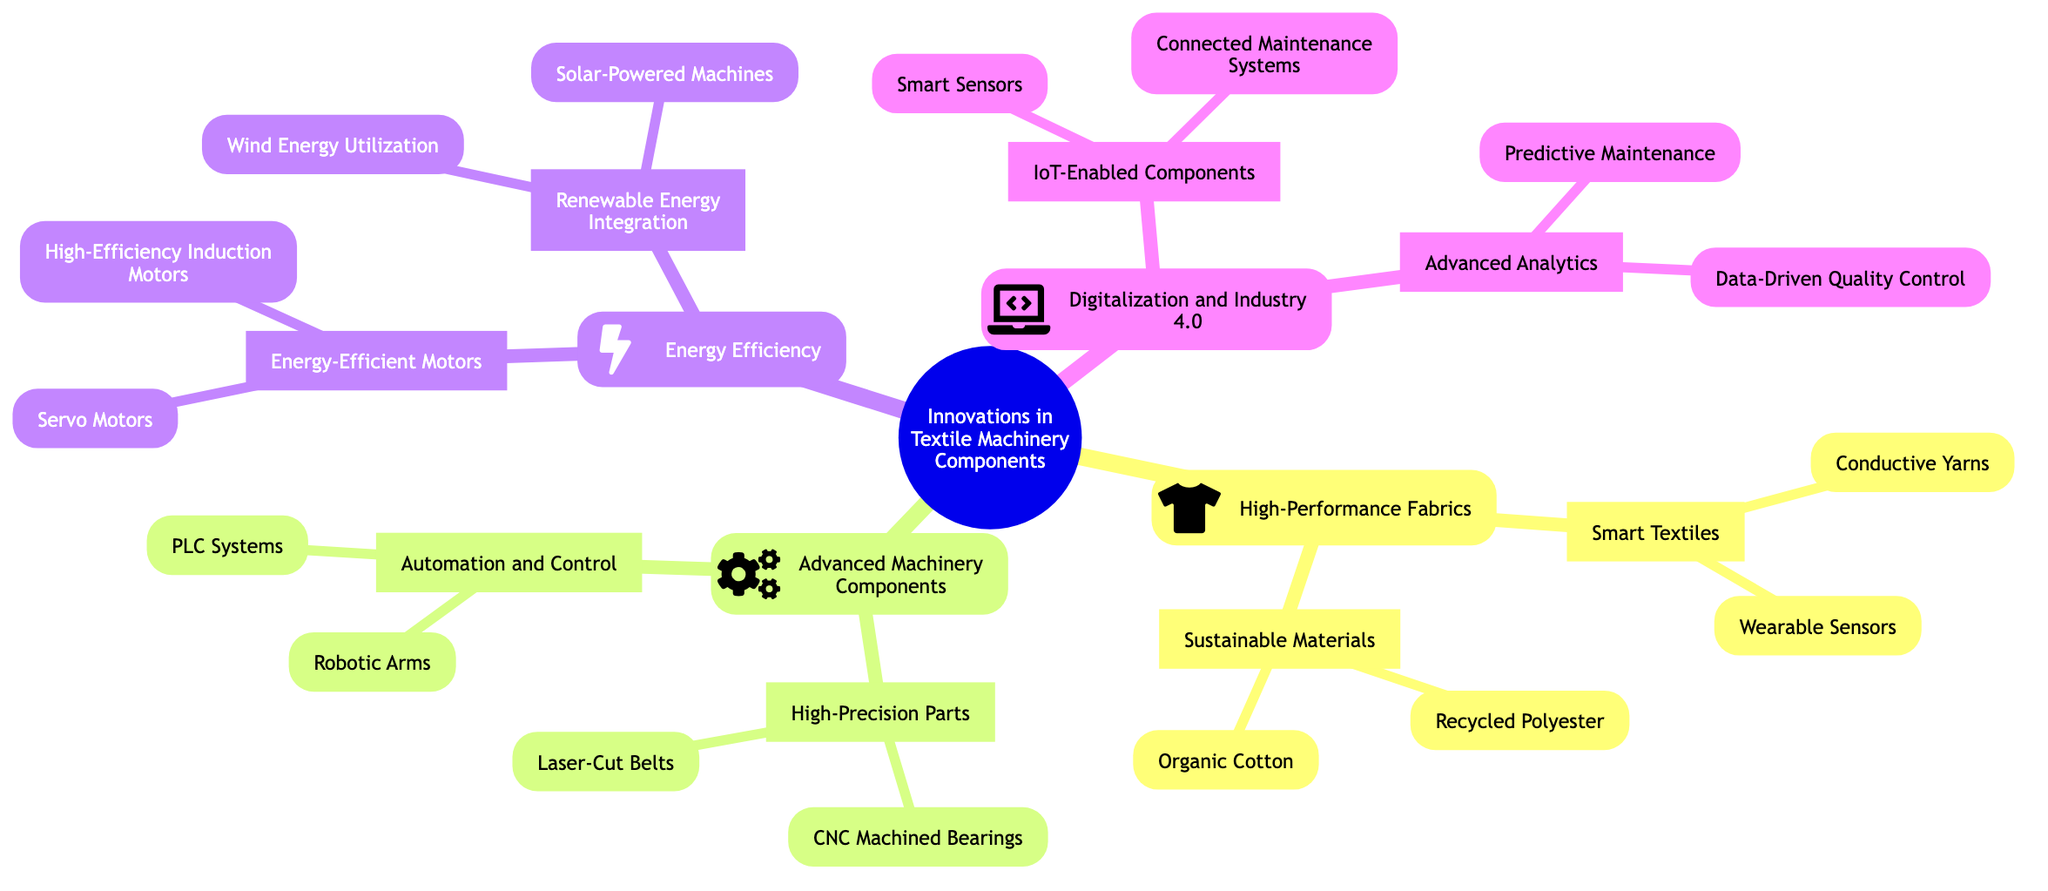What is the central topic of the mind map? The central topic is the core theme of the mind map, which is stated at the root node. It is 'Innovations in Textile Machinery Components'.
Answer: Innovations in Textile Machinery Components How many main branches are there? The diagram features four main branches stemming from the central topic. These branches are 'High-Performance Fabrics', 'Advanced Machinery Components', 'Energy Efficiency', and 'Digitalization and Industry 4.0'.
Answer: 4 Which branch includes 'Wearable Sensors'? 'Wearable Sensors' is located under the 'Smart Textiles' sub-branch of the 'High-Performance Fabrics' branch, showing that it's a specific topic under that general category.
Answer: High-Performance Fabrics What type of materials are featured under 'Sustainable Materials'? 'Sustainable Materials' includes 'Recycled Polyester' and 'Organic Cotton', both of which are identified within its sub-branch under 'High-Performance Fabrics'.
Answer: Recycled Polyester, Organic Cotton What components are listed under 'Energy-Efficient Motors'? The sub-branch 'Energy-Efficient Motors' lists 'Servo Motors' and 'High-Efficiency Induction Motors', making these key components in energy-efficient technology for textile machinery.
Answer: Servo Motors, High-Efficiency Induction Motors How are 'Robotic Arms' categorized in the mind map? 'Robotic Arms' is categorized under the 'Automation and Control' sub-branch of the 'Advanced Machinery Components' branch, indicating its role in advancing machinery through automation.
Answer: Advanced Machinery Components What are the two main components of 'IoT-Enabled Components'? The 'IoT-Enabled Components' sub-branch lists 'Smart Sensors' and 'Connected Maintenance Systems' as its main components, essential for digital integration in textile machinery.
Answer: Smart Sensors, Connected Maintenance Systems Which two innovations contribute to 'Renewable Energy Integration'? The 'Renewable Energy Integration' sub-branch features 'Solar-Powered Machines' and 'Wind Energy Utilization', demonstrating approaches toward sustainability in machinery.
Answer: Solar-Powered Machines, Wind Energy Utilization How does 'Advanced Analytics' relate to the overall theme of the diagram? 'Advanced Analytics', found in the 'Digitalization and Industry 4.0' branch, relates to the theme by showcasing the utilization of data analysis to improve maintenance and quality control in the textile industry.
Answer: Digitalization and Industry 4.0 